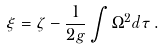Convert formula to latex. <formula><loc_0><loc_0><loc_500><loc_500>\xi = \zeta - \frac { 1 } { 2 g } \int \Omega ^ { 2 } d \tau \, .</formula> 